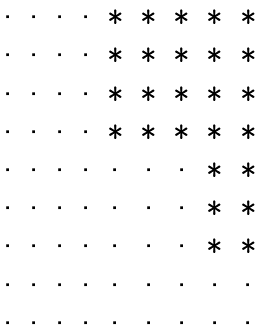Convert formula to latex. <formula><loc_0><loc_0><loc_500><loc_500>\begin{matrix} \cdot & \cdot & \cdot & \cdot & * & * & * & * & * \\ \cdot & \cdot & \cdot & \cdot & * & * & * & * & * \\ \cdot & \cdot & \cdot & \cdot & * & * & * & * & * \\ \cdot & \cdot & \cdot & \cdot & * & * & * & * & * \\ \cdot & \cdot & \cdot & \cdot & \cdot & \cdot & \cdot & * & * \\ \cdot & \cdot & \cdot & \cdot & \cdot & \cdot & \cdot & * & * \\ \cdot & \cdot & \cdot & \cdot & \cdot & \cdot & \cdot & * & * \\ \cdot & \cdot & \cdot & \cdot & \cdot & \cdot & \cdot & \cdot & \cdot \\ \cdot & \cdot & \cdot & \cdot & \cdot & \cdot & \cdot & \cdot & \cdot \end{matrix}</formula> 